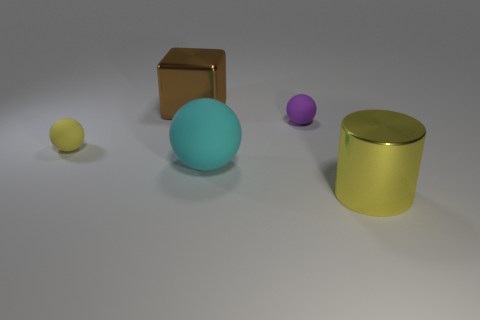Subtract all tiny rubber balls. How many balls are left? 1 Add 3 cyan rubber objects. How many objects exist? 8 Subtract all spheres. How many objects are left? 2 Add 5 large balls. How many large balls are left? 6 Add 5 blue cubes. How many blue cubes exist? 5 Subtract 0 blue cylinders. How many objects are left? 5 Subtract all cyan cubes. Subtract all red spheres. How many cubes are left? 1 Subtract all brown shiny things. Subtract all purple matte objects. How many objects are left? 3 